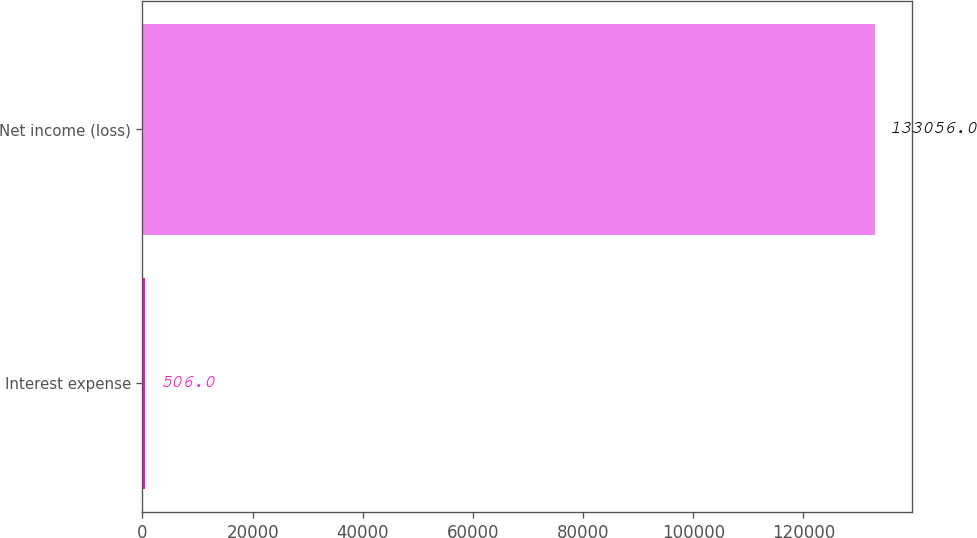<chart> <loc_0><loc_0><loc_500><loc_500><bar_chart><fcel>Interest expense<fcel>Net income (loss)<nl><fcel>506<fcel>133056<nl></chart> 